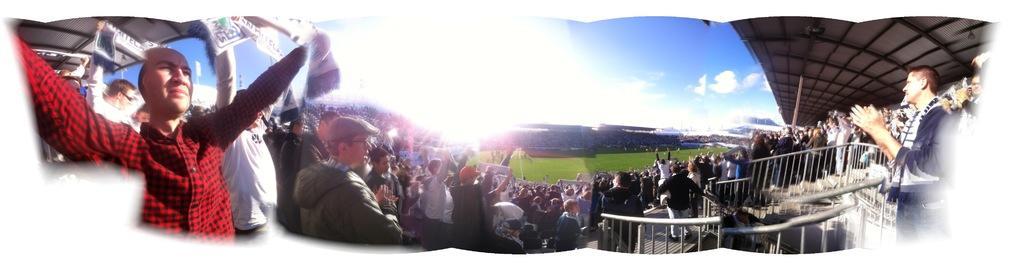Describe this image in one or two sentences. In this image I can see group of people some are standing and some are sitting. The person in front wearing red and black color shirt, background I can see few other persons standing, few stairs and sky is in blue and white color. 